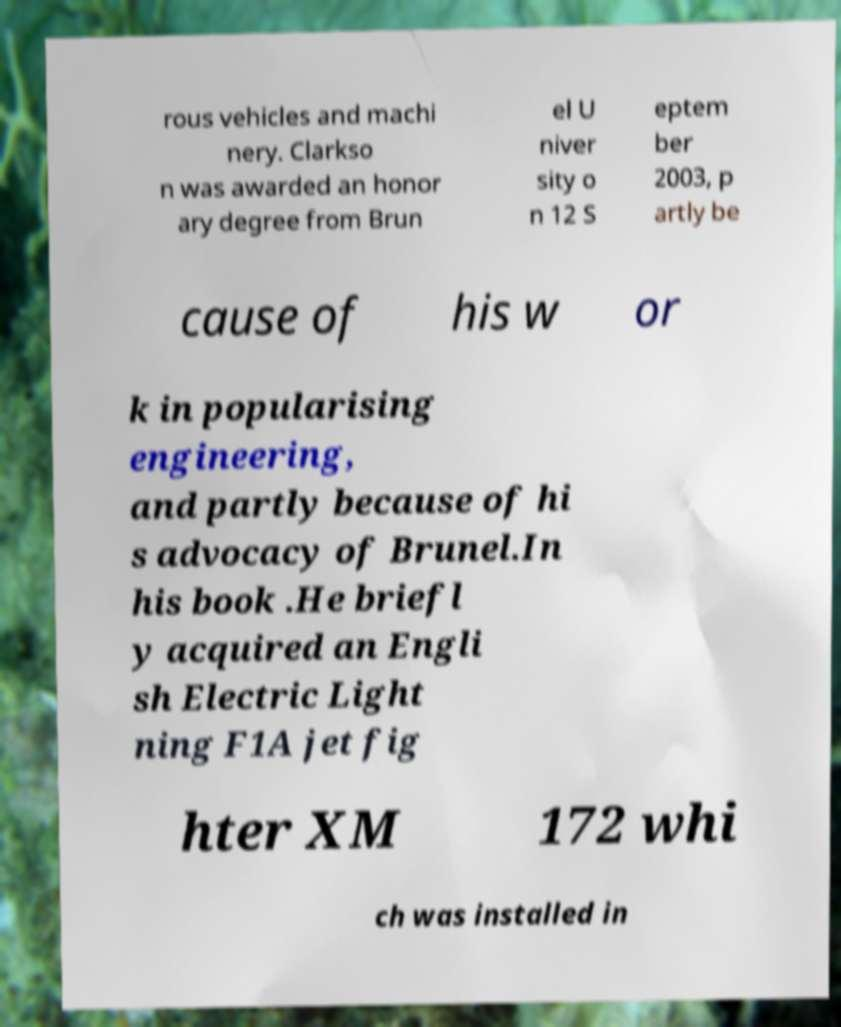What messages or text are displayed in this image? I need them in a readable, typed format. rous vehicles and machi nery. Clarkso n was awarded an honor ary degree from Brun el U niver sity o n 12 S eptem ber 2003, p artly be cause of his w or k in popularising engineering, and partly because of hi s advocacy of Brunel.In his book .He briefl y acquired an Engli sh Electric Light ning F1A jet fig hter XM 172 whi ch was installed in 